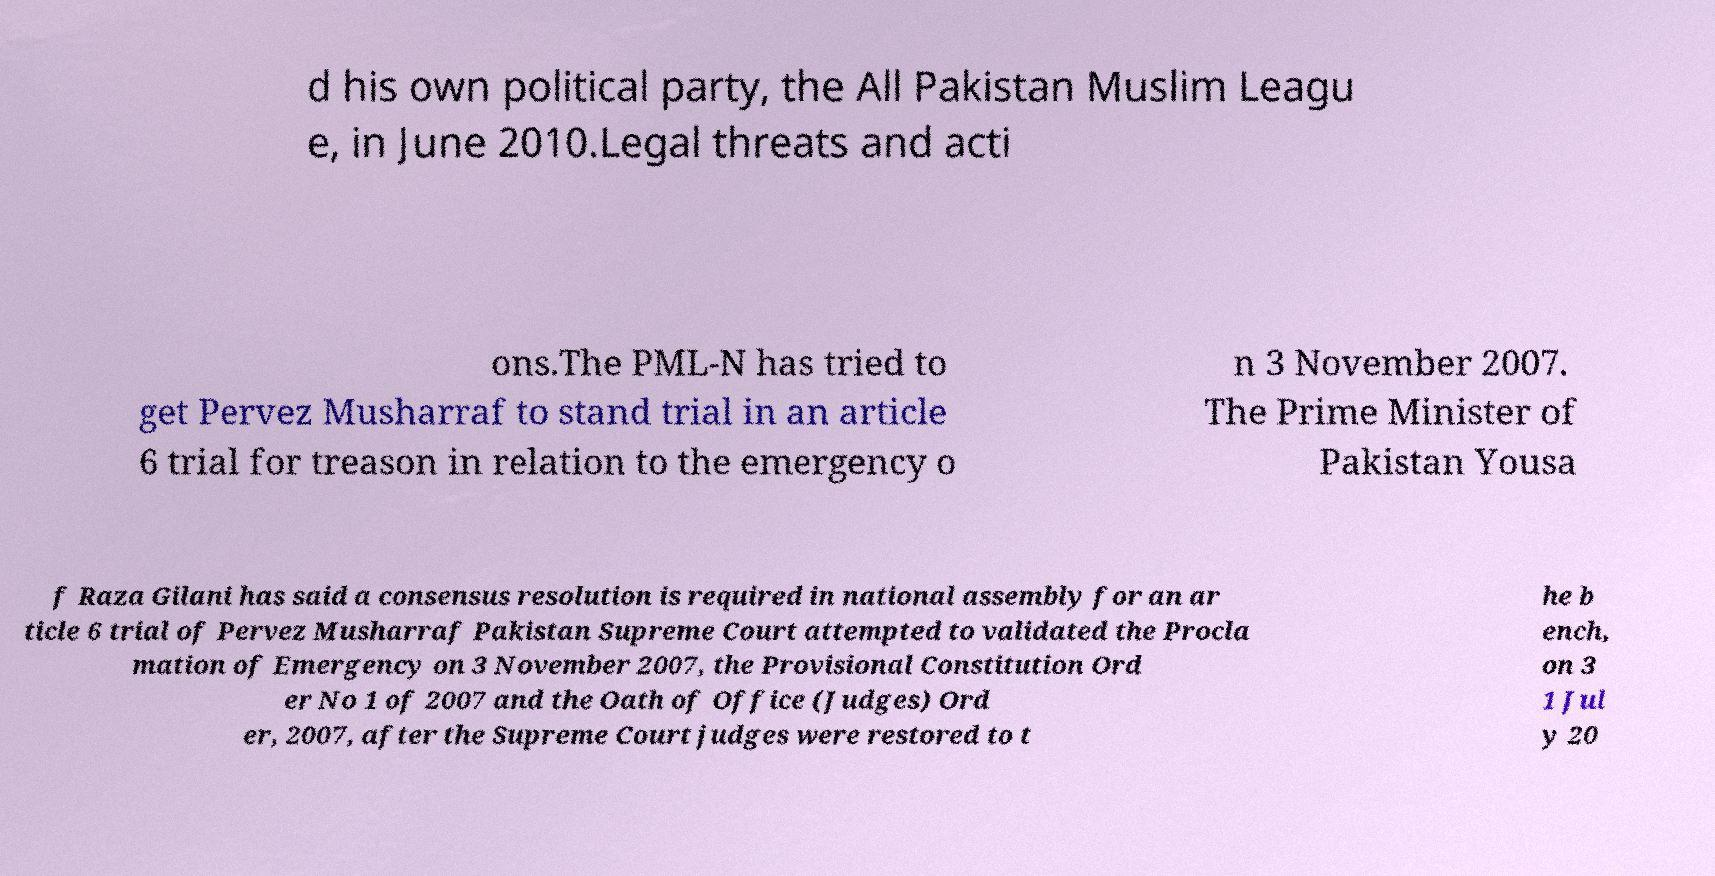For documentation purposes, I need the text within this image transcribed. Could you provide that? d his own political party, the All Pakistan Muslim Leagu e, in June 2010.Legal threats and acti ons.The PML-N has tried to get Pervez Musharraf to stand trial in an article 6 trial for treason in relation to the emergency o n 3 November 2007. The Prime Minister of Pakistan Yousa f Raza Gilani has said a consensus resolution is required in national assembly for an ar ticle 6 trial of Pervez Musharraf Pakistan Supreme Court attempted to validated the Procla mation of Emergency on 3 November 2007, the Provisional Constitution Ord er No 1 of 2007 and the Oath of Office (Judges) Ord er, 2007, after the Supreme Court judges were restored to t he b ench, on 3 1 Jul y 20 